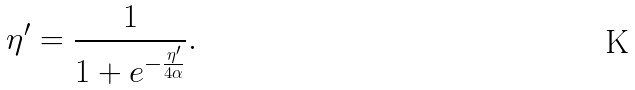<formula> <loc_0><loc_0><loc_500><loc_500>\eta ^ { \prime } = \frac { 1 } { 1 + e ^ { - \frac { \eta ^ { \prime } } { 4 \alpha } } } .</formula> 